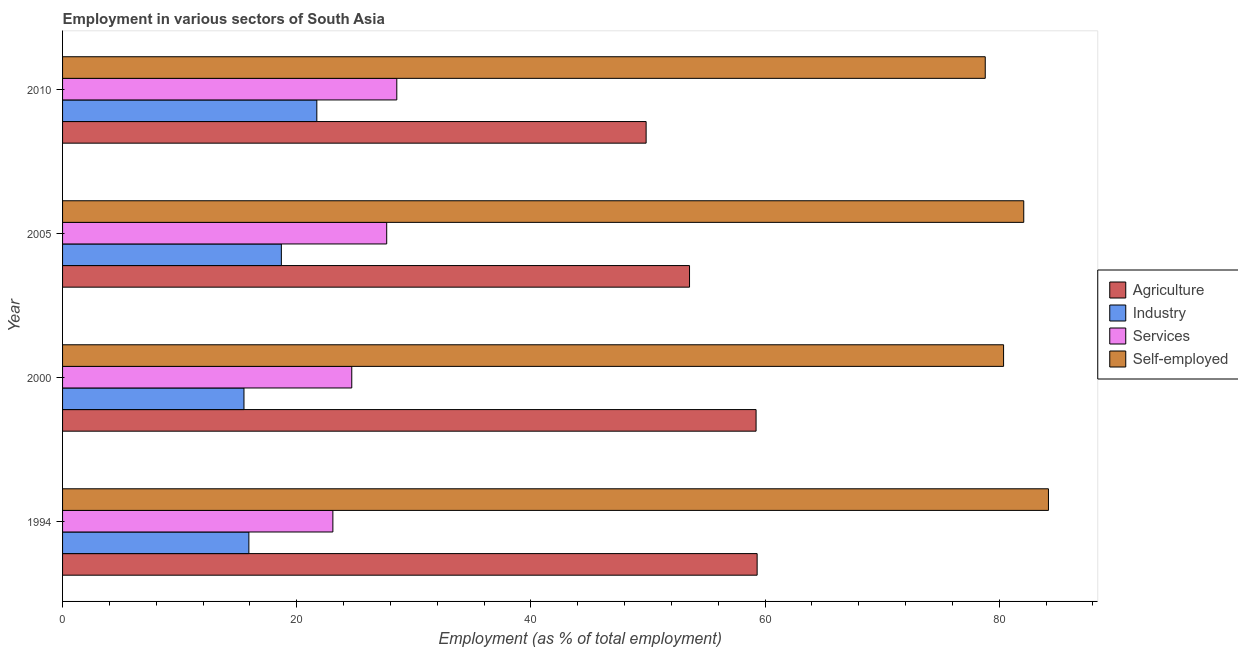Are the number of bars on each tick of the Y-axis equal?
Give a very brief answer. Yes. How many bars are there on the 2nd tick from the top?
Provide a short and direct response. 4. What is the label of the 3rd group of bars from the top?
Offer a terse response. 2000. What is the percentage of self employed workers in 2000?
Provide a short and direct response. 80.37. Across all years, what is the maximum percentage of workers in services?
Provide a succinct answer. 28.55. Across all years, what is the minimum percentage of self employed workers?
Provide a succinct answer. 78.81. In which year was the percentage of workers in agriculture maximum?
Ensure brevity in your answer.  1994. In which year was the percentage of workers in agriculture minimum?
Your response must be concise. 2010. What is the total percentage of workers in industry in the graph?
Provide a short and direct response. 71.81. What is the difference between the percentage of self employed workers in 1994 and that in 2000?
Offer a terse response. 3.83. What is the difference between the percentage of workers in agriculture in 2005 and the percentage of self employed workers in 1994?
Your answer should be compact. -30.66. What is the average percentage of workers in industry per year?
Your response must be concise. 17.95. In the year 1994, what is the difference between the percentage of workers in services and percentage of self employed workers?
Your response must be concise. -61.12. Is the percentage of workers in services in 2005 less than that in 2010?
Keep it short and to the point. Yes. What is the difference between the highest and the second highest percentage of workers in agriculture?
Make the answer very short. 0.09. What is the difference between the highest and the lowest percentage of workers in services?
Offer a very short reply. 5.46. In how many years, is the percentage of workers in industry greater than the average percentage of workers in industry taken over all years?
Provide a succinct answer. 2. What does the 3rd bar from the top in 2005 represents?
Keep it short and to the point. Industry. What does the 4th bar from the bottom in 2005 represents?
Provide a succinct answer. Self-employed. How many years are there in the graph?
Ensure brevity in your answer.  4. Are the values on the major ticks of X-axis written in scientific E-notation?
Offer a very short reply. No. Does the graph contain any zero values?
Your answer should be very brief. No. How many legend labels are there?
Your answer should be very brief. 4. What is the title of the graph?
Offer a terse response. Employment in various sectors of South Asia. Does "Periodicity assessment" appear as one of the legend labels in the graph?
Provide a short and direct response. No. What is the label or title of the X-axis?
Make the answer very short. Employment (as % of total employment). What is the label or title of the Y-axis?
Give a very brief answer. Year. What is the Employment (as % of total employment) in Agriculture in 1994?
Offer a terse response. 59.32. What is the Employment (as % of total employment) in Industry in 1994?
Your answer should be very brief. 15.91. What is the Employment (as % of total employment) in Services in 1994?
Offer a very short reply. 23.09. What is the Employment (as % of total employment) of Self-employed in 1994?
Provide a short and direct response. 84.21. What is the Employment (as % of total employment) of Agriculture in 2000?
Give a very brief answer. 59.23. What is the Employment (as % of total employment) in Industry in 2000?
Ensure brevity in your answer.  15.49. What is the Employment (as % of total employment) in Services in 2000?
Provide a short and direct response. 24.7. What is the Employment (as % of total employment) of Self-employed in 2000?
Your answer should be very brief. 80.37. What is the Employment (as % of total employment) of Agriculture in 2005?
Offer a very short reply. 53.55. What is the Employment (as % of total employment) in Industry in 2005?
Provide a succinct answer. 18.69. What is the Employment (as % of total employment) in Services in 2005?
Ensure brevity in your answer.  27.68. What is the Employment (as % of total employment) of Self-employed in 2005?
Keep it short and to the point. 82.1. What is the Employment (as % of total employment) of Agriculture in 2010?
Your answer should be compact. 49.84. What is the Employment (as % of total employment) in Industry in 2010?
Provide a short and direct response. 21.72. What is the Employment (as % of total employment) of Services in 2010?
Your answer should be compact. 28.55. What is the Employment (as % of total employment) in Self-employed in 2010?
Ensure brevity in your answer.  78.81. Across all years, what is the maximum Employment (as % of total employment) in Agriculture?
Your answer should be compact. 59.32. Across all years, what is the maximum Employment (as % of total employment) of Industry?
Offer a very short reply. 21.72. Across all years, what is the maximum Employment (as % of total employment) in Services?
Offer a terse response. 28.55. Across all years, what is the maximum Employment (as % of total employment) of Self-employed?
Provide a succinct answer. 84.21. Across all years, what is the minimum Employment (as % of total employment) of Agriculture?
Offer a terse response. 49.84. Across all years, what is the minimum Employment (as % of total employment) of Industry?
Ensure brevity in your answer.  15.49. Across all years, what is the minimum Employment (as % of total employment) of Services?
Ensure brevity in your answer.  23.09. Across all years, what is the minimum Employment (as % of total employment) in Self-employed?
Make the answer very short. 78.81. What is the total Employment (as % of total employment) of Agriculture in the graph?
Provide a short and direct response. 221.95. What is the total Employment (as % of total employment) of Industry in the graph?
Provide a short and direct response. 71.81. What is the total Employment (as % of total employment) in Services in the graph?
Ensure brevity in your answer.  104.02. What is the total Employment (as % of total employment) in Self-employed in the graph?
Your answer should be compact. 325.48. What is the difference between the Employment (as % of total employment) in Agriculture in 1994 and that in 2000?
Your answer should be very brief. 0.09. What is the difference between the Employment (as % of total employment) in Industry in 1994 and that in 2000?
Keep it short and to the point. 0.42. What is the difference between the Employment (as % of total employment) of Services in 1994 and that in 2000?
Provide a short and direct response. -1.61. What is the difference between the Employment (as % of total employment) of Self-employed in 1994 and that in 2000?
Your answer should be very brief. 3.83. What is the difference between the Employment (as % of total employment) in Agriculture in 1994 and that in 2005?
Your answer should be very brief. 5.77. What is the difference between the Employment (as % of total employment) of Industry in 1994 and that in 2005?
Give a very brief answer. -2.77. What is the difference between the Employment (as % of total employment) in Services in 1994 and that in 2005?
Provide a short and direct response. -4.6. What is the difference between the Employment (as % of total employment) in Self-employed in 1994 and that in 2005?
Your response must be concise. 2.11. What is the difference between the Employment (as % of total employment) of Agriculture in 1994 and that in 2010?
Make the answer very short. 9.48. What is the difference between the Employment (as % of total employment) in Industry in 1994 and that in 2010?
Offer a terse response. -5.8. What is the difference between the Employment (as % of total employment) in Services in 1994 and that in 2010?
Give a very brief answer. -5.46. What is the difference between the Employment (as % of total employment) in Self-employed in 1994 and that in 2010?
Make the answer very short. 5.4. What is the difference between the Employment (as % of total employment) in Agriculture in 2000 and that in 2005?
Ensure brevity in your answer.  5.68. What is the difference between the Employment (as % of total employment) of Industry in 2000 and that in 2005?
Give a very brief answer. -3.19. What is the difference between the Employment (as % of total employment) in Services in 2000 and that in 2005?
Keep it short and to the point. -2.98. What is the difference between the Employment (as % of total employment) in Self-employed in 2000 and that in 2005?
Provide a succinct answer. -1.72. What is the difference between the Employment (as % of total employment) in Agriculture in 2000 and that in 2010?
Your answer should be very brief. 9.39. What is the difference between the Employment (as % of total employment) in Industry in 2000 and that in 2010?
Ensure brevity in your answer.  -6.22. What is the difference between the Employment (as % of total employment) in Services in 2000 and that in 2010?
Make the answer very short. -3.85. What is the difference between the Employment (as % of total employment) of Self-employed in 2000 and that in 2010?
Provide a succinct answer. 1.57. What is the difference between the Employment (as % of total employment) of Agriculture in 2005 and that in 2010?
Make the answer very short. 3.71. What is the difference between the Employment (as % of total employment) of Industry in 2005 and that in 2010?
Make the answer very short. -3.03. What is the difference between the Employment (as % of total employment) of Services in 2005 and that in 2010?
Make the answer very short. -0.86. What is the difference between the Employment (as % of total employment) in Self-employed in 2005 and that in 2010?
Your answer should be compact. 3.29. What is the difference between the Employment (as % of total employment) of Agriculture in 1994 and the Employment (as % of total employment) of Industry in 2000?
Offer a terse response. 43.83. What is the difference between the Employment (as % of total employment) of Agriculture in 1994 and the Employment (as % of total employment) of Services in 2000?
Give a very brief answer. 34.62. What is the difference between the Employment (as % of total employment) of Agriculture in 1994 and the Employment (as % of total employment) of Self-employed in 2000?
Offer a very short reply. -21.05. What is the difference between the Employment (as % of total employment) in Industry in 1994 and the Employment (as % of total employment) in Services in 2000?
Give a very brief answer. -8.79. What is the difference between the Employment (as % of total employment) in Industry in 1994 and the Employment (as % of total employment) in Self-employed in 2000?
Offer a very short reply. -64.46. What is the difference between the Employment (as % of total employment) in Services in 1994 and the Employment (as % of total employment) in Self-employed in 2000?
Your answer should be very brief. -57.29. What is the difference between the Employment (as % of total employment) of Agriculture in 1994 and the Employment (as % of total employment) of Industry in 2005?
Make the answer very short. 40.64. What is the difference between the Employment (as % of total employment) of Agriculture in 1994 and the Employment (as % of total employment) of Services in 2005?
Make the answer very short. 31.64. What is the difference between the Employment (as % of total employment) in Agriculture in 1994 and the Employment (as % of total employment) in Self-employed in 2005?
Provide a short and direct response. -22.77. What is the difference between the Employment (as % of total employment) in Industry in 1994 and the Employment (as % of total employment) in Services in 2005?
Give a very brief answer. -11.77. What is the difference between the Employment (as % of total employment) of Industry in 1994 and the Employment (as % of total employment) of Self-employed in 2005?
Your answer should be very brief. -66.18. What is the difference between the Employment (as % of total employment) in Services in 1994 and the Employment (as % of total employment) in Self-employed in 2005?
Provide a succinct answer. -59.01. What is the difference between the Employment (as % of total employment) of Agriculture in 1994 and the Employment (as % of total employment) of Industry in 2010?
Your answer should be compact. 37.61. What is the difference between the Employment (as % of total employment) of Agriculture in 1994 and the Employment (as % of total employment) of Services in 2010?
Your answer should be compact. 30.78. What is the difference between the Employment (as % of total employment) in Agriculture in 1994 and the Employment (as % of total employment) in Self-employed in 2010?
Ensure brevity in your answer.  -19.48. What is the difference between the Employment (as % of total employment) of Industry in 1994 and the Employment (as % of total employment) of Services in 2010?
Provide a succinct answer. -12.63. What is the difference between the Employment (as % of total employment) of Industry in 1994 and the Employment (as % of total employment) of Self-employed in 2010?
Offer a very short reply. -62.89. What is the difference between the Employment (as % of total employment) in Services in 1994 and the Employment (as % of total employment) in Self-employed in 2010?
Your answer should be very brief. -55.72. What is the difference between the Employment (as % of total employment) of Agriculture in 2000 and the Employment (as % of total employment) of Industry in 2005?
Your answer should be compact. 40.55. What is the difference between the Employment (as % of total employment) of Agriculture in 2000 and the Employment (as % of total employment) of Services in 2005?
Your response must be concise. 31.55. What is the difference between the Employment (as % of total employment) in Agriculture in 2000 and the Employment (as % of total employment) in Self-employed in 2005?
Give a very brief answer. -22.86. What is the difference between the Employment (as % of total employment) of Industry in 2000 and the Employment (as % of total employment) of Services in 2005?
Offer a terse response. -12.19. What is the difference between the Employment (as % of total employment) of Industry in 2000 and the Employment (as % of total employment) of Self-employed in 2005?
Provide a succinct answer. -66.6. What is the difference between the Employment (as % of total employment) in Services in 2000 and the Employment (as % of total employment) in Self-employed in 2005?
Your answer should be very brief. -57.4. What is the difference between the Employment (as % of total employment) of Agriculture in 2000 and the Employment (as % of total employment) of Industry in 2010?
Ensure brevity in your answer.  37.52. What is the difference between the Employment (as % of total employment) in Agriculture in 2000 and the Employment (as % of total employment) in Services in 2010?
Provide a short and direct response. 30.69. What is the difference between the Employment (as % of total employment) of Agriculture in 2000 and the Employment (as % of total employment) of Self-employed in 2010?
Make the answer very short. -19.57. What is the difference between the Employment (as % of total employment) in Industry in 2000 and the Employment (as % of total employment) in Services in 2010?
Your response must be concise. -13.05. What is the difference between the Employment (as % of total employment) in Industry in 2000 and the Employment (as % of total employment) in Self-employed in 2010?
Keep it short and to the point. -63.31. What is the difference between the Employment (as % of total employment) in Services in 2000 and the Employment (as % of total employment) in Self-employed in 2010?
Your answer should be compact. -54.11. What is the difference between the Employment (as % of total employment) of Agriculture in 2005 and the Employment (as % of total employment) of Industry in 2010?
Your answer should be very brief. 31.83. What is the difference between the Employment (as % of total employment) of Agriculture in 2005 and the Employment (as % of total employment) of Services in 2010?
Give a very brief answer. 25. What is the difference between the Employment (as % of total employment) in Agriculture in 2005 and the Employment (as % of total employment) in Self-employed in 2010?
Ensure brevity in your answer.  -25.26. What is the difference between the Employment (as % of total employment) in Industry in 2005 and the Employment (as % of total employment) in Services in 2010?
Ensure brevity in your answer.  -9.86. What is the difference between the Employment (as % of total employment) in Industry in 2005 and the Employment (as % of total employment) in Self-employed in 2010?
Your answer should be very brief. -60.12. What is the difference between the Employment (as % of total employment) in Services in 2005 and the Employment (as % of total employment) in Self-employed in 2010?
Make the answer very short. -51.12. What is the average Employment (as % of total employment) of Agriculture per year?
Your answer should be compact. 55.49. What is the average Employment (as % of total employment) in Industry per year?
Provide a succinct answer. 17.95. What is the average Employment (as % of total employment) in Services per year?
Provide a succinct answer. 26.01. What is the average Employment (as % of total employment) in Self-employed per year?
Ensure brevity in your answer.  81.37. In the year 1994, what is the difference between the Employment (as % of total employment) in Agriculture and Employment (as % of total employment) in Industry?
Ensure brevity in your answer.  43.41. In the year 1994, what is the difference between the Employment (as % of total employment) of Agriculture and Employment (as % of total employment) of Services?
Offer a very short reply. 36.24. In the year 1994, what is the difference between the Employment (as % of total employment) of Agriculture and Employment (as % of total employment) of Self-employed?
Your answer should be very brief. -24.88. In the year 1994, what is the difference between the Employment (as % of total employment) in Industry and Employment (as % of total employment) in Services?
Offer a terse response. -7.17. In the year 1994, what is the difference between the Employment (as % of total employment) in Industry and Employment (as % of total employment) in Self-employed?
Offer a terse response. -68.29. In the year 1994, what is the difference between the Employment (as % of total employment) in Services and Employment (as % of total employment) in Self-employed?
Make the answer very short. -61.12. In the year 2000, what is the difference between the Employment (as % of total employment) of Agriculture and Employment (as % of total employment) of Industry?
Your answer should be very brief. 43.74. In the year 2000, what is the difference between the Employment (as % of total employment) in Agriculture and Employment (as % of total employment) in Services?
Give a very brief answer. 34.53. In the year 2000, what is the difference between the Employment (as % of total employment) of Agriculture and Employment (as % of total employment) of Self-employed?
Offer a very short reply. -21.14. In the year 2000, what is the difference between the Employment (as % of total employment) of Industry and Employment (as % of total employment) of Services?
Make the answer very short. -9.21. In the year 2000, what is the difference between the Employment (as % of total employment) in Industry and Employment (as % of total employment) in Self-employed?
Ensure brevity in your answer.  -64.88. In the year 2000, what is the difference between the Employment (as % of total employment) of Services and Employment (as % of total employment) of Self-employed?
Your answer should be compact. -55.67. In the year 2005, what is the difference between the Employment (as % of total employment) of Agriculture and Employment (as % of total employment) of Industry?
Your answer should be very brief. 34.86. In the year 2005, what is the difference between the Employment (as % of total employment) in Agriculture and Employment (as % of total employment) in Services?
Provide a succinct answer. 25.87. In the year 2005, what is the difference between the Employment (as % of total employment) in Agriculture and Employment (as % of total employment) in Self-employed?
Give a very brief answer. -28.55. In the year 2005, what is the difference between the Employment (as % of total employment) of Industry and Employment (as % of total employment) of Services?
Provide a short and direct response. -9. In the year 2005, what is the difference between the Employment (as % of total employment) of Industry and Employment (as % of total employment) of Self-employed?
Provide a short and direct response. -63.41. In the year 2005, what is the difference between the Employment (as % of total employment) in Services and Employment (as % of total employment) in Self-employed?
Provide a succinct answer. -54.41. In the year 2010, what is the difference between the Employment (as % of total employment) in Agriculture and Employment (as % of total employment) in Industry?
Make the answer very short. 28.13. In the year 2010, what is the difference between the Employment (as % of total employment) in Agriculture and Employment (as % of total employment) in Services?
Keep it short and to the point. 21.3. In the year 2010, what is the difference between the Employment (as % of total employment) in Agriculture and Employment (as % of total employment) in Self-employed?
Ensure brevity in your answer.  -28.96. In the year 2010, what is the difference between the Employment (as % of total employment) in Industry and Employment (as % of total employment) in Services?
Ensure brevity in your answer.  -6.83. In the year 2010, what is the difference between the Employment (as % of total employment) in Industry and Employment (as % of total employment) in Self-employed?
Your response must be concise. -57.09. In the year 2010, what is the difference between the Employment (as % of total employment) in Services and Employment (as % of total employment) in Self-employed?
Keep it short and to the point. -50.26. What is the ratio of the Employment (as % of total employment) of Agriculture in 1994 to that in 2000?
Your answer should be compact. 1. What is the ratio of the Employment (as % of total employment) of Services in 1994 to that in 2000?
Your answer should be compact. 0.93. What is the ratio of the Employment (as % of total employment) of Self-employed in 1994 to that in 2000?
Offer a terse response. 1.05. What is the ratio of the Employment (as % of total employment) in Agriculture in 1994 to that in 2005?
Make the answer very short. 1.11. What is the ratio of the Employment (as % of total employment) in Industry in 1994 to that in 2005?
Provide a short and direct response. 0.85. What is the ratio of the Employment (as % of total employment) in Services in 1994 to that in 2005?
Offer a terse response. 0.83. What is the ratio of the Employment (as % of total employment) of Self-employed in 1994 to that in 2005?
Your answer should be compact. 1.03. What is the ratio of the Employment (as % of total employment) in Agriculture in 1994 to that in 2010?
Offer a very short reply. 1.19. What is the ratio of the Employment (as % of total employment) in Industry in 1994 to that in 2010?
Your response must be concise. 0.73. What is the ratio of the Employment (as % of total employment) in Services in 1994 to that in 2010?
Your response must be concise. 0.81. What is the ratio of the Employment (as % of total employment) of Self-employed in 1994 to that in 2010?
Ensure brevity in your answer.  1.07. What is the ratio of the Employment (as % of total employment) in Agriculture in 2000 to that in 2005?
Make the answer very short. 1.11. What is the ratio of the Employment (as % of total employment) in Industry in 2000 to that in 2005?
Make the answer very short. 0.83. What is the ratio of the Employment (as % of total employment) in Services in 2000 to that in 2005?
Offer a very short reply. 0.89. What is the ratio of the Employment (as % of total employment) in Agriculture in 2000 to that in 2010?
Your response must be concise. 1.19. What is the ratio of the Employment (as % of total employment) in Industry in 2000 to that in 2010?
Your response must be concise. 0.71. What is the ratio of the Employment (as % of total employment) in Services in 2000 to that in 2010?
Offer a very short reply. 0.87. What is the ratio of the Employment (as % of total employment) of Self-employed in 2000 to that in 2010?
Give a very brief answer. 1.02. What is the ratio of the Employment (as % of total employment) of Agriculture in 2005 to that in 2010?
Provide a short and direct response. 1.07. What is the ratio of the Employment (as % of total employment) of Industry in 2005 to that in 2010?
Your answer should be compact. 0.86. What is the ratio of the Employment (as % of total employment) of Services in 2005 to that in 2010?
Provide a short and direct response. 0.97. What is the ratio of the Employment (as % of total employment) of Self-employed in 2005 to that in 2010?
Give a very brief answer. 1.04. What is the difference between the highest and the second highest Employment (as % of total employment) of Agriculture?
Keep it short and to the point. 0.09. What is the difference between the highest and the second highest Employment (as % of total employment) of Industry?
Make the answer very short. 3.03. What is the difference between the highest and the second highest Employment (as % of total employment) in Services?
Give a very brief answer. 0.86. What is the difference between the highest and the second highest Employment (as % of total employment) of Self-employed?
Give a very brief answer. 2.11. What is the difference between the highest and the lowest Employment (as % of total employment) of Agriculture?
Your answer should be very brief. 9.48. What is the difference between the highest and the lowest Employment (as % of total employment) of Industry?
Your answer should be compact. 6.22. What is the difference between the highest and the lowest Employment (as % of total employment) of Services?
Offer a very short reply. 5.46. What is the difference between the highest and the lowest Employment (as % of total employment) in Self-employed?
Provide a succinct answer. 5.4. 